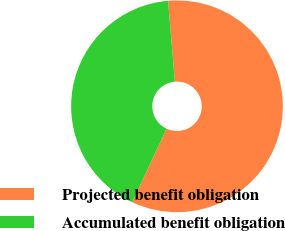Convert chart. <chart><loc_0><loc_0><loc_500><loc_500><pie_chart><fcel>Projected benefit obligation<fcel>Accumulated benefit obligation<nl><fcel>58.28%<fcel>41.72%<nl></chart> 